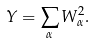<formula> <loc_0><loc_0><loc_500><loc_500>Y = \sum _ { \alpha } W _ { \alpha } ^ { 2 } .</formula> 